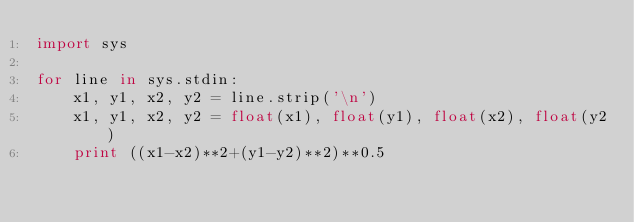<code> <loc_0><loc_0><loc_500><loc_500><_Python_>import sys

for line in sys.stdin:
    x1, y1, x2, y2 = line.strip('\n')
    x1, y1, x2, y2 = float(x1), float(y1), float(x2), float(y2)
    print ((x1-x2)**2+(y1-y2)**2)**0.5</code> 